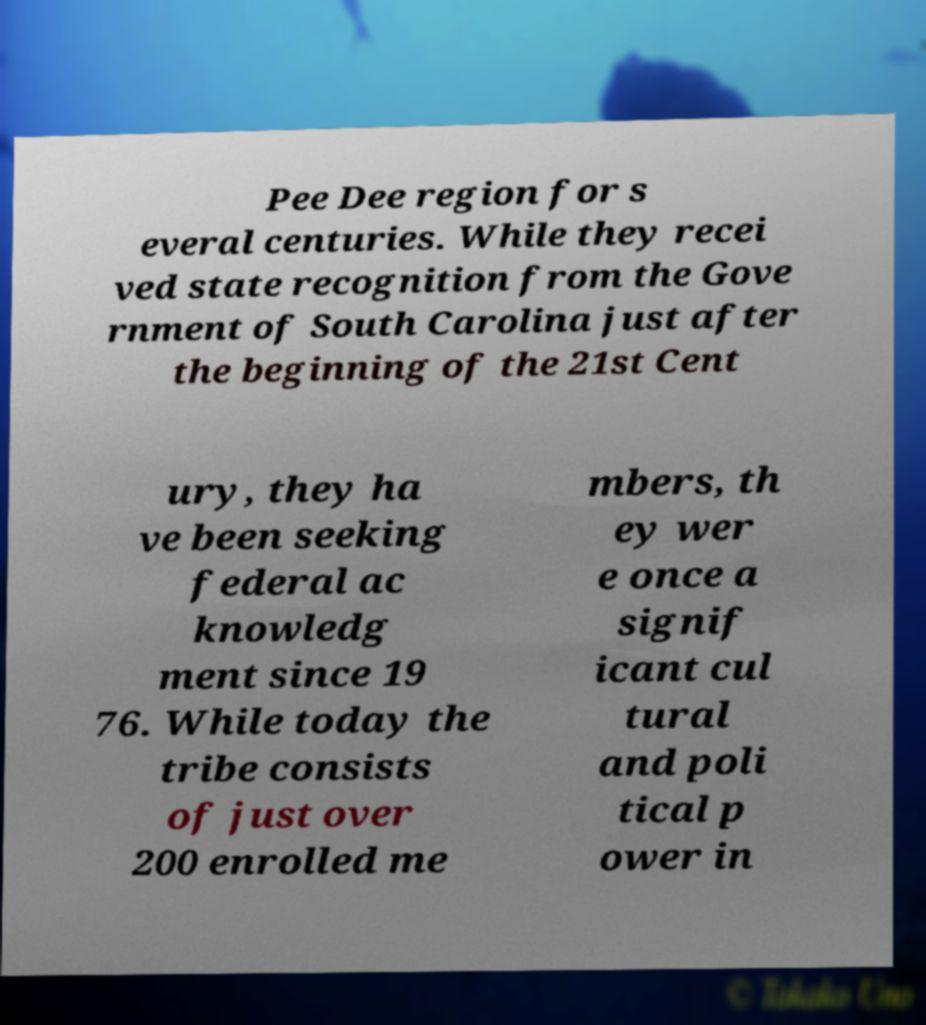What messages or text are displayed in this image? I need them in a readable, typed format. Pee Dee region for s everal centuries. While they recei ved state recognition from the Gove rnment of South Carolina just after the beginning of the 21st Cent ury, they ha ve been seeking federal ac knowledg ment since 19 76. While today the tribe consists of just over 200 enrolled me mbers, th ey wer e once a signif icant cul tural and poli tical p ower in 